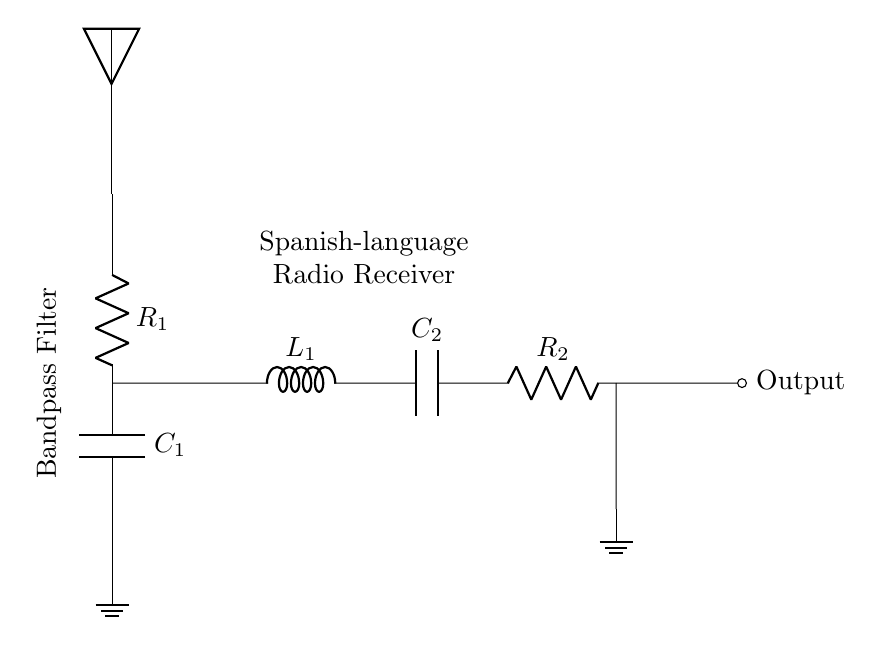What type of filter is represented in the circuit? The circuit diagram shows a bandpass filter, which allows a specific frequency range to pass while blocking frequencies outside of that range. The label "Bandpass Filter" confirms this.
Answer: Bandpass filter What is the role of the component labeled R1 in the circuit? R1 is a resistor that is likely used for impedance matching or to limit the current entering the filter to protect the components downstream. Resistors generally serve to limit current in the circuit.
Answer: Resistor How many capacitors are present in this circuit? The circuit includes two capacitors, labeled C1 and C2, which are essential for frequency selection in the bandpass filter setup.
Answer: Two What is the output of the circuit labeled as? The output of the circuit is labeled as "Output," indicating the point where the filtered signal can be obtained or transmitted after processing through the bandpass filter.
Answer: Output Which components are used to create the resonant circuit in this filter? The resonant circuit is created using the inductor L1 and capacitor C2. The combination of these components determines the frequency response of the filter, allowing it to pass specific frequencies while attenuating others.
Answer: L1 and C2 